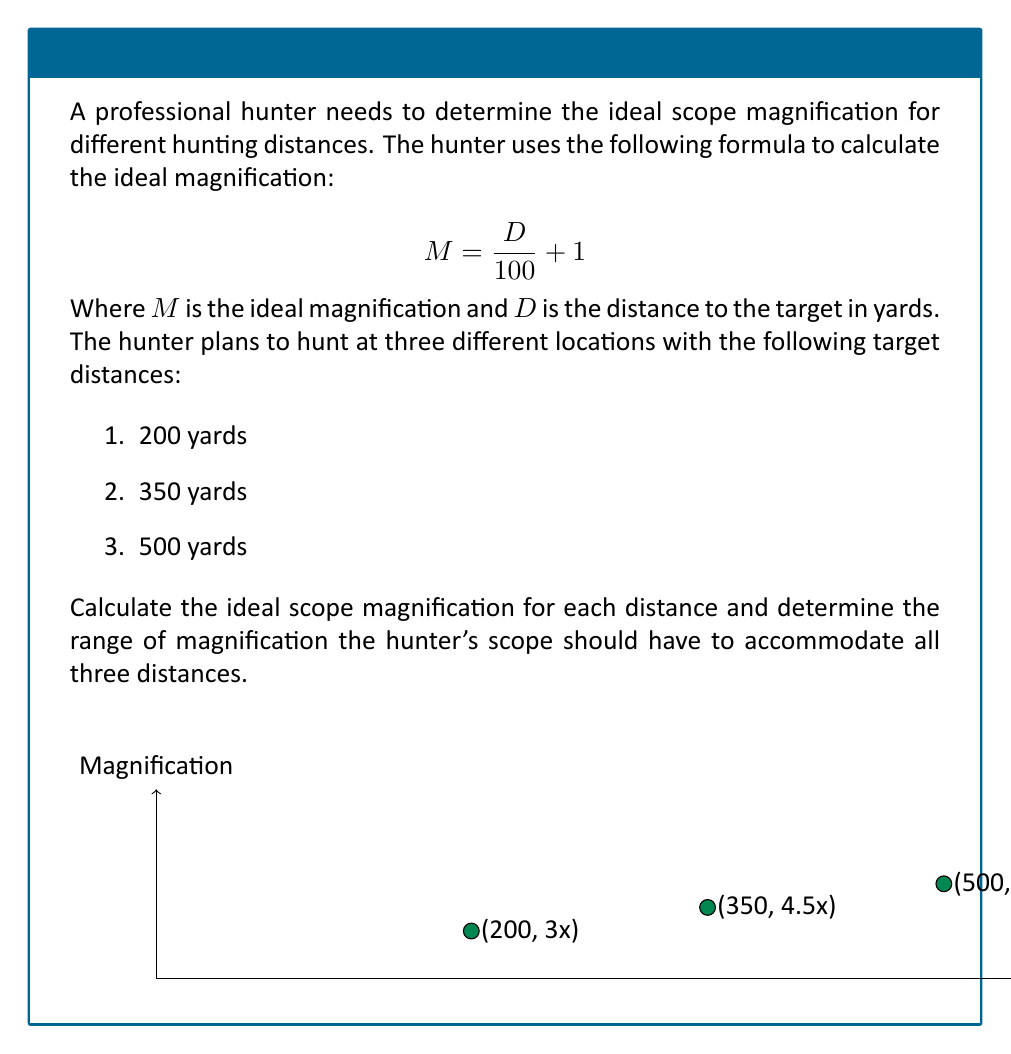Could you help me with this problem? Let's solve this problem step by step:

1. We'll use the given formula to calculate the ideal magnification for each distance:

   $$ M = \frac{D}{100} + 1 $$

2. For 200 yards:
   $$ M_1 = \frac{200}{100} + 1 = 2 + 1 = 3x $$

3. For 350 yards:
   $$ M_2 = \frac{350}{100} + 1 = 3.5 + 1 = 4.5x $$

4. For 500 yards:
   $$ M_3 = \frac{500}{100} + 1 = 5 + 1 = 6x $$

5. To determine the range of magnification the hunter's scope should have:
   - Minimum magnification: 3x (for 200 yards)
   - Maximum magnification: 6x (for 500 yards)

Therefore, the hunter's scope should have a magnification range of 3x to 6x to accommodate all three hunting distances.
Answer: 3x-6x magnification range 